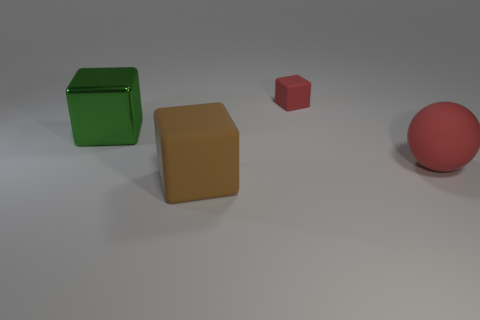Add 2 red things. How many objects exist? 6 Subtract all big shiny blocks. How many blocks are left? 2 Subtract all blocks. How many objects are left? 1 Subtract 1 blocks. How many blocks are left? 2 Subtract 0 purple cylinders. How many objects are left? 4 Subtract all yellow balls. Subtract all yellow blocks. How many balls are left? 1 Subtract all red cubes. Subtract all gray blocks. How many objects are left? 3 Add 2 big red things. How many big red things are left? 3 Add 1 tiny matte blocks. How many tiny matte blocks exist? 2 Subtract all red blocks. How many blocks are left? 2 